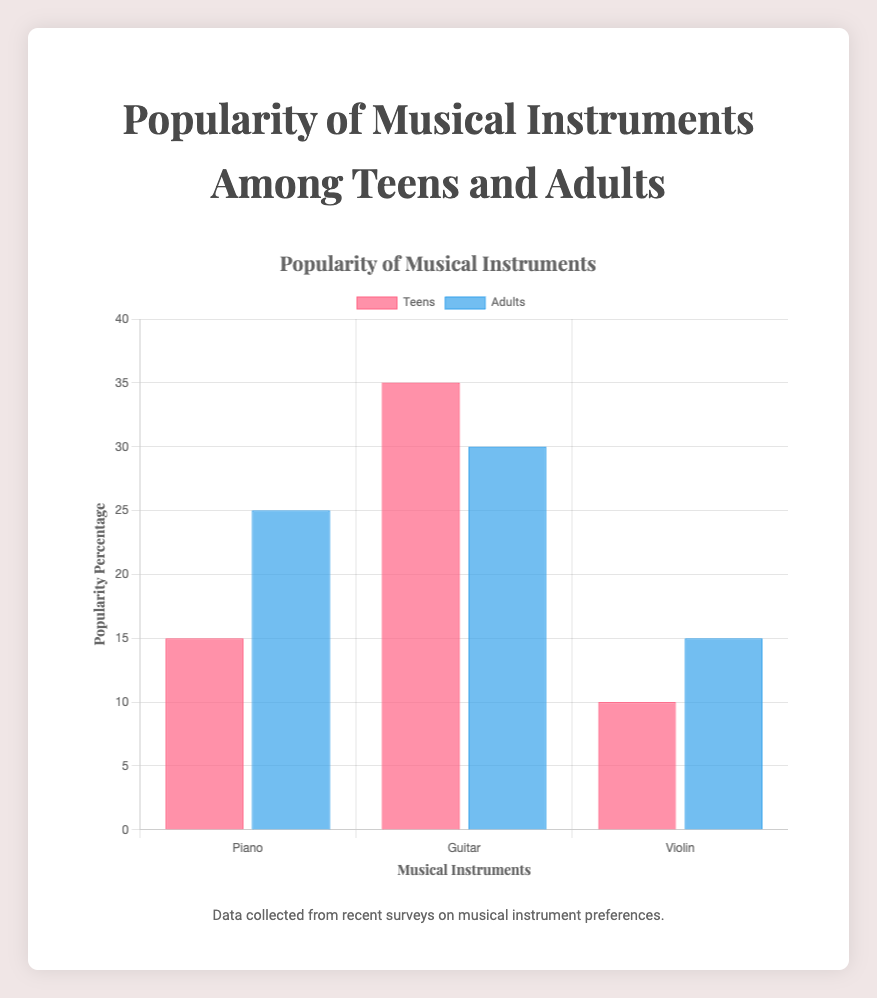Which instrument is more popular among teens than adults? The Guitar is more popular among teens with 35%, compared to adults with 30%. This is identified by comparing the height of the bars labeled 'Guitar' for both age groups.
Answer: Guitar What is the least popular instrument among teens? The Violin is the least popular among teens with 10%. This is observed by noting that the bar for Violin in the 'Teens' group is the shortest.
Answer: Violin Which age group shows a higher preference for the Piano? Adults show a higher preference for the Piano with 25% compared to teens with 15%. This is determined by comparing the heights of the bars for Piano in both age groups.
Answer: Adults What is the total popularity percentage of all instruments among adults? Sum the popularity percentages for Piano, Guitar, and Violin among adults: 25% + 30% + 15% = 70%.
Answer: 70% Which instrument has the smallest difference in popularity between teens and adults? The Violin has the smallest difference in popularity between teens and adults. The difference is 15% - 10% = 5%.
Answer: Violin Between the Guitar and the Piano, which instrument has a higher combined popularity percentage across both age groups? The Guitar has a higher combined popularity. Adding the percentages for Guitar gives 35% (teens) + 30% (adults) = 65%, whereas for Piano, it is 15% (teens) + 25% (adults) = 40%.
Answer: Guitar What is the average popularity percentage of the Violin across both age groups? The average popularity percentage of the Violin is (10% + 15%) / 2 = 12.5%.
Answer: 12.5% Which color represents the data for adults in the chart? The data for adults are represented by blue bars. This information is typically provided in the legend of the chart.
Answer: Blue How much more popular is the Guitar compared to the Violin among teens? The Guitar is 35% - 10% = 25% more popular than the Violin among teens. This is determined by subtracting the popularity percentage of the Violin from that of the Guitar for the teens' age group.
Answer: 25% By how much does the popularity of the Piano increase from teens to adults? The popularity of the Piano increases by 25% (adults) - 15% (teens) = 10%. This is calculated by subtracting the popularity percentage of the Piano for teens from that for adults.
Answer: 10% 